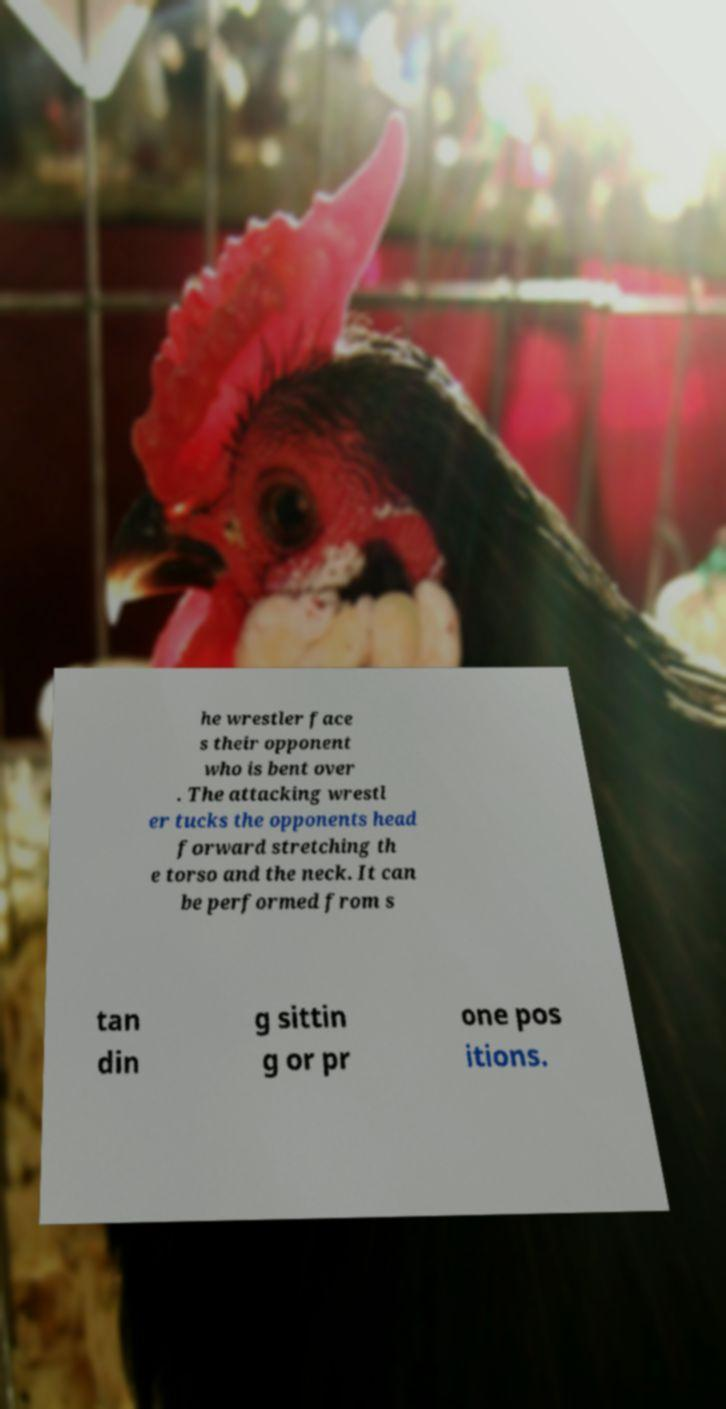Please read and relay the text visible in this image. What does it say? he wrestler face s their opponent who is bent over . The attacking wrestl er tucks the opponents head forward stretching th e torso and the neck. It can be performed from s tan din g sittin g or pr one pos itions. 